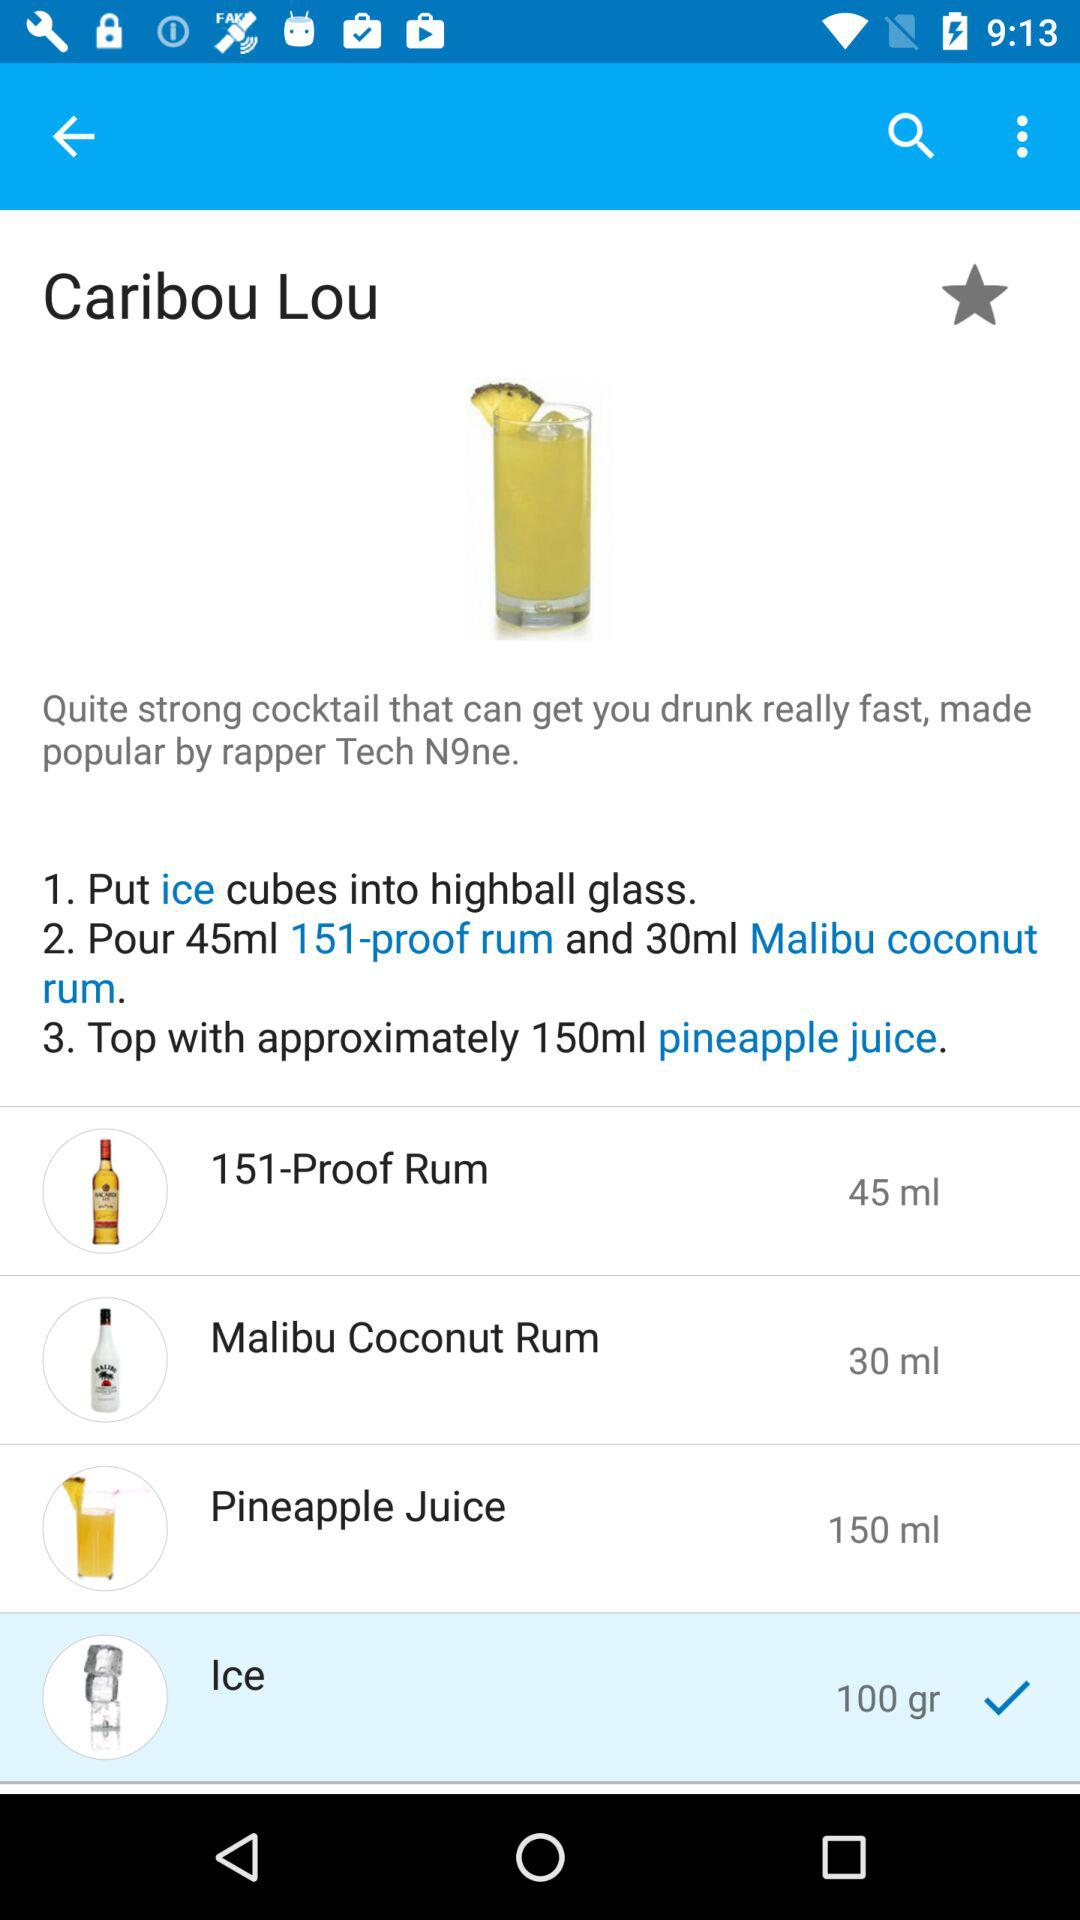How much pineapple juice is required? The required pineapple juice is approximately 150 ml. 